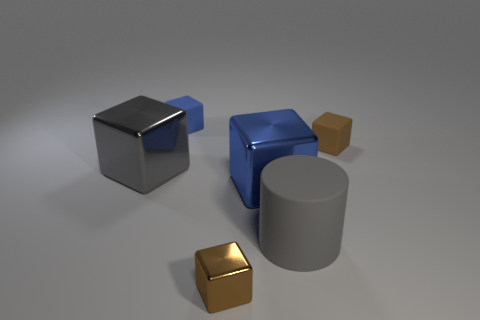How many brown cubes must be subtracted to get 1 brown cubes? 1 Subtract all green blocks. Subtract all red balls. How many blocks are left? 5 Add 1 blue blocks. How many objects exist? 7 Subtract all cubes. How many objects are left? 1 Subtract all small blue matte things. Subtract all large cubes. How many objects are left? 3 Add 4 blue metal objects. How many blue metal objects are left? 5 Add 5 large purple rubber spheres. How many large purple rubber spheres exist? 5 Subtract 0 green balls. How many objects are left? 6 